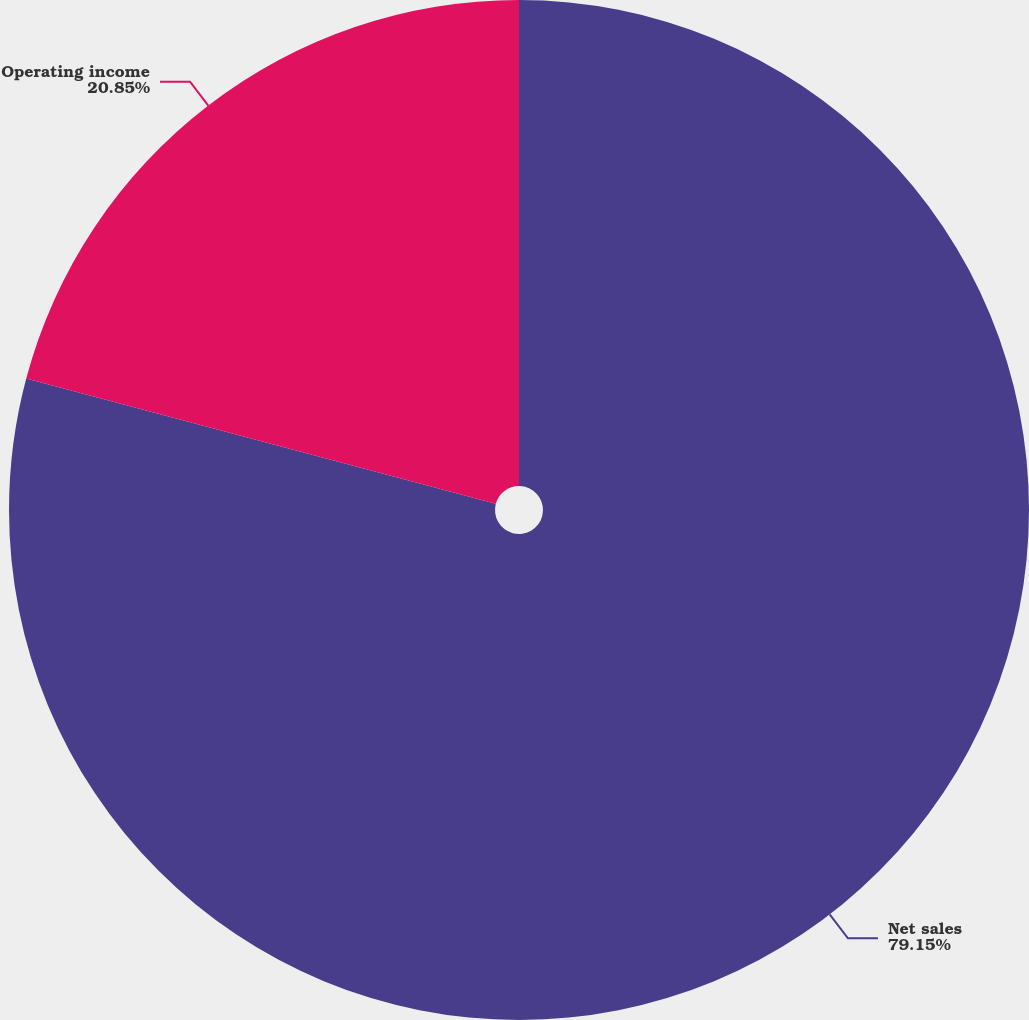Convert chart. <chart><loc_0><loc_0><loc_500><loc_500><pie_chart><fcel>Net sales<fcel>Operating income<nl><fcel>79.15%<fcel>20.85%<nl></chart> 